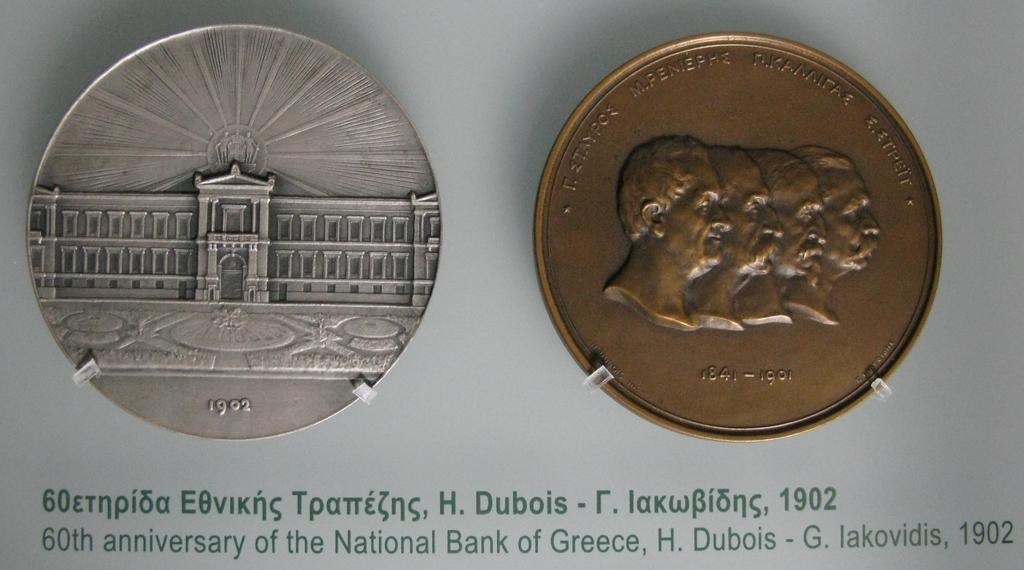What year anniversary is it?
Your answer should be very brief. 60th. What year is shown?
Your answer should be very brief. 1902. 